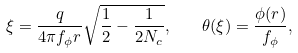Convert formula to latex. <formula><loc_0><loc_0><loc_500><loc_500>\xi = \frac { q } { 4 \pi f _ { \phi } r } \sqrt { \frac { 1 } { 2 } - \frac { 1 } { 2 N _ { c } } } , \quad \theta ( \xi ) = \frac { \phi ( r ) } { f _ { \phi } } ,</formula> 